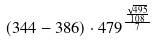Convert formula to latex. <formula><loc_0><loc_0><loc_500><loc_500>( 3 4 4 - 3 8 6 ) \cdot 4 7 9 ^ { \frac { \frac { \sqrt { 4 9 5 } } { 1 0 8 } } { 7 } }</formula> 